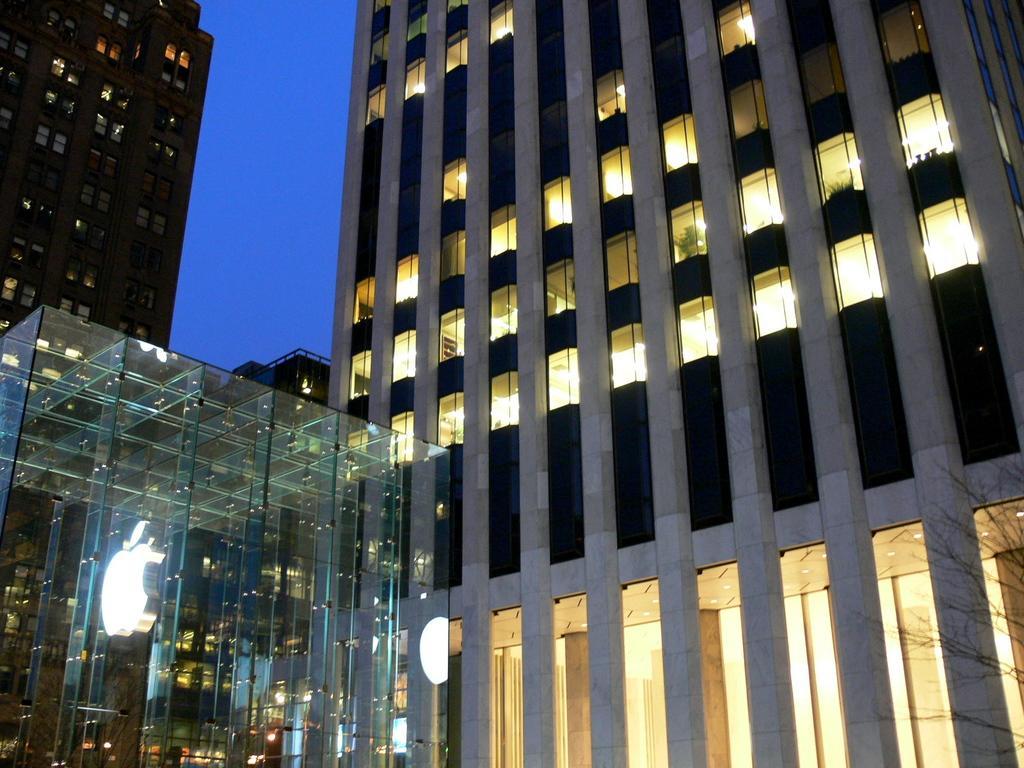How would you summarize this image in a sentence or two? In this image we can see the buildings. We can see the light inside the buildings. At the top we can see the sky. In the foreground we can see a logo. 